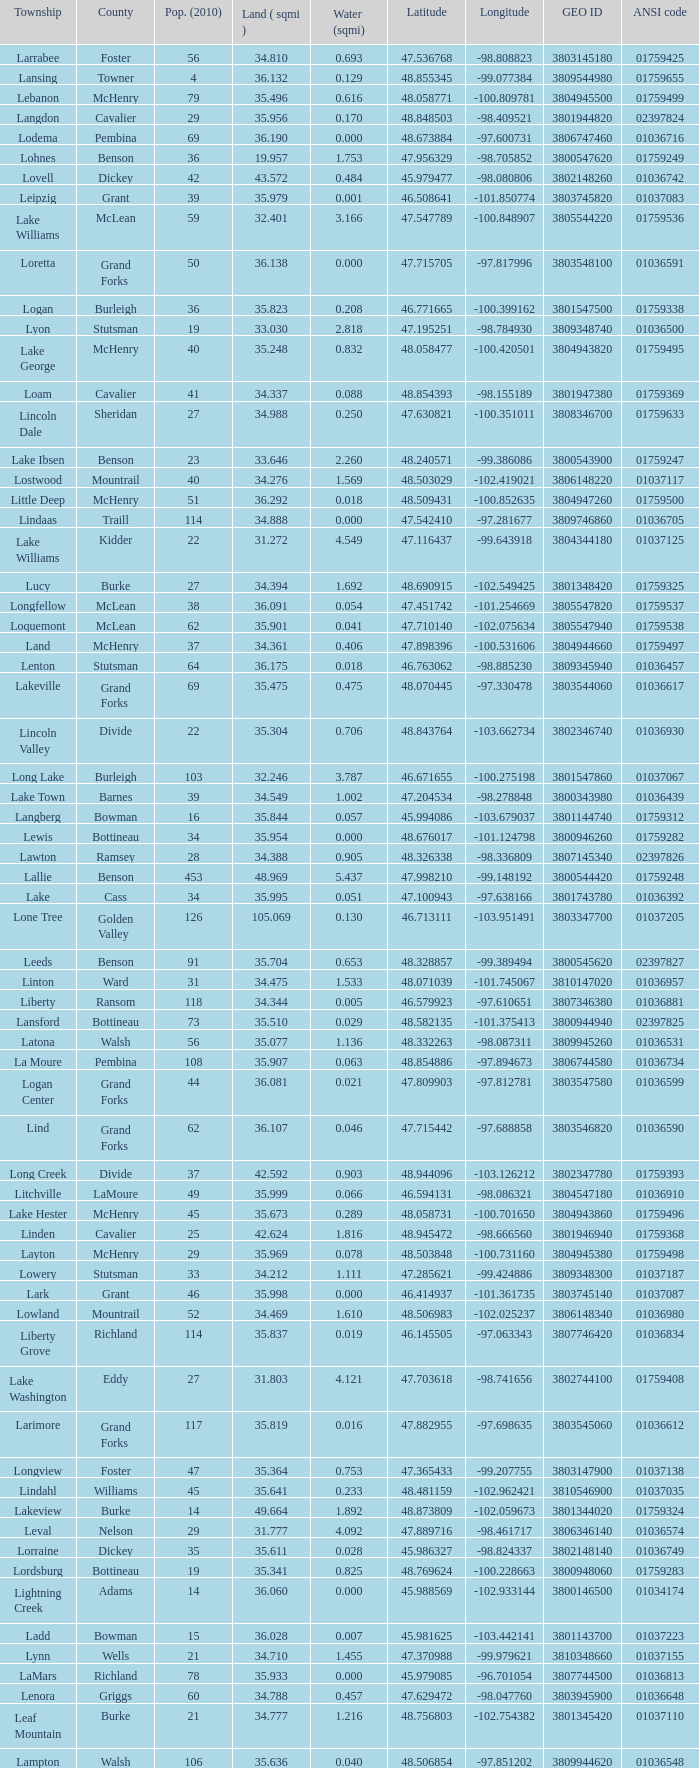What is latitude when 2010 population is 24 and water is more than 0.319? None. 